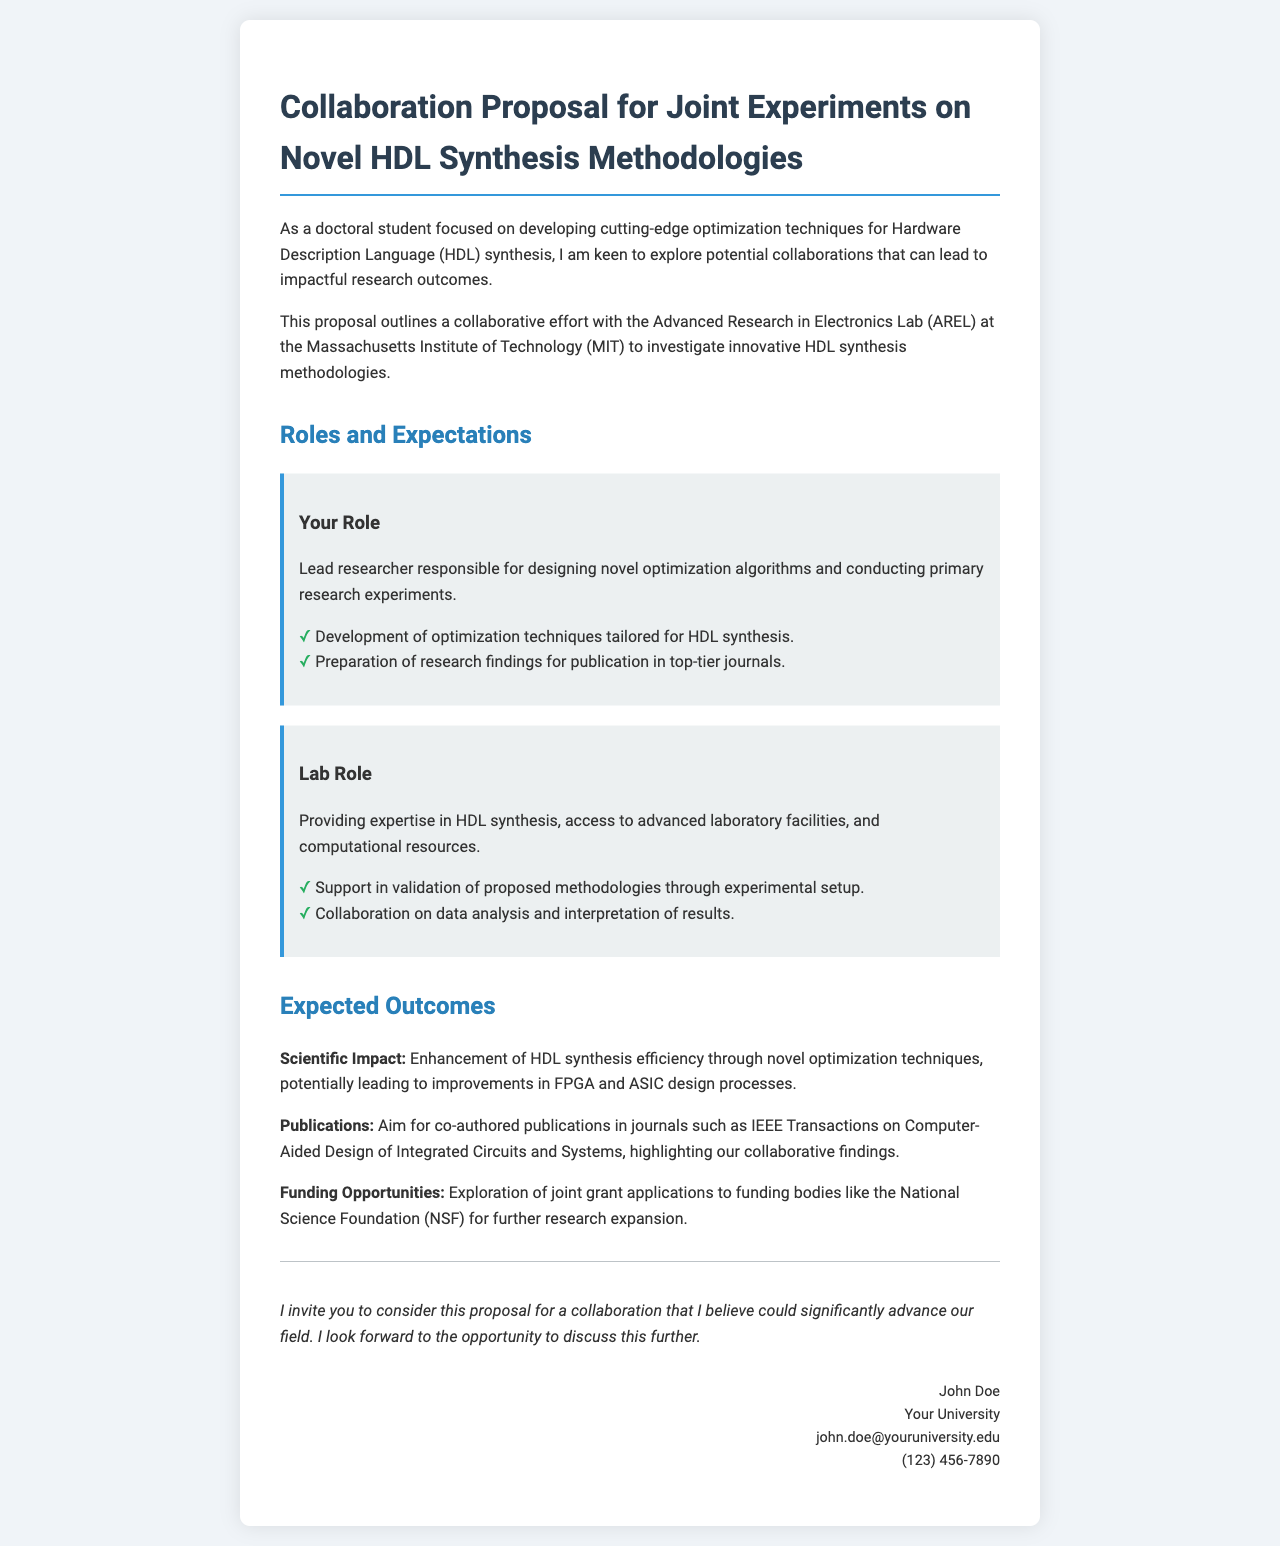What is the title of the proposal? The title is prominently stated at the beginning of the document.
Answer: Collaboration Proposal for Joint Experiments on Novel HDL Synthesis Methodologies Who is the lead researcher? The lead researcher is mentioned in the contact section at the end.
Answer: John Doe What is one deliverable for the lab's role? The lab's role section lists specific responsibilities.
Answer: Collaboration on data analysis and interpretation of results What is the expected scientific impact of the collaboration? The expected outcomes section outlines the benefits of the collaboration.
Answer: Enhancement of HDL synthesis efficiency Which journal is mentioned for potential publications? The expected outcomes section discusses publication goals.
Answer: IEEE Transactions on Computer-Aided Design of Integrated Circuits and Systems What type of funding opportunities are mentioned? Funding opportunities are detailed in the expected outcomes section.
Answer: Joint grant applications to funding bodies What is the contact email for the lead researcher? The contact information provides essential communication details.
Answer: john.doe@youruniversity.edu What role will the Advanced Research in Electronics Lab play? The roles are specifically mentioned in the document, providing clarity on contributions.
Answer: Providing expertise in HDL synthesis 